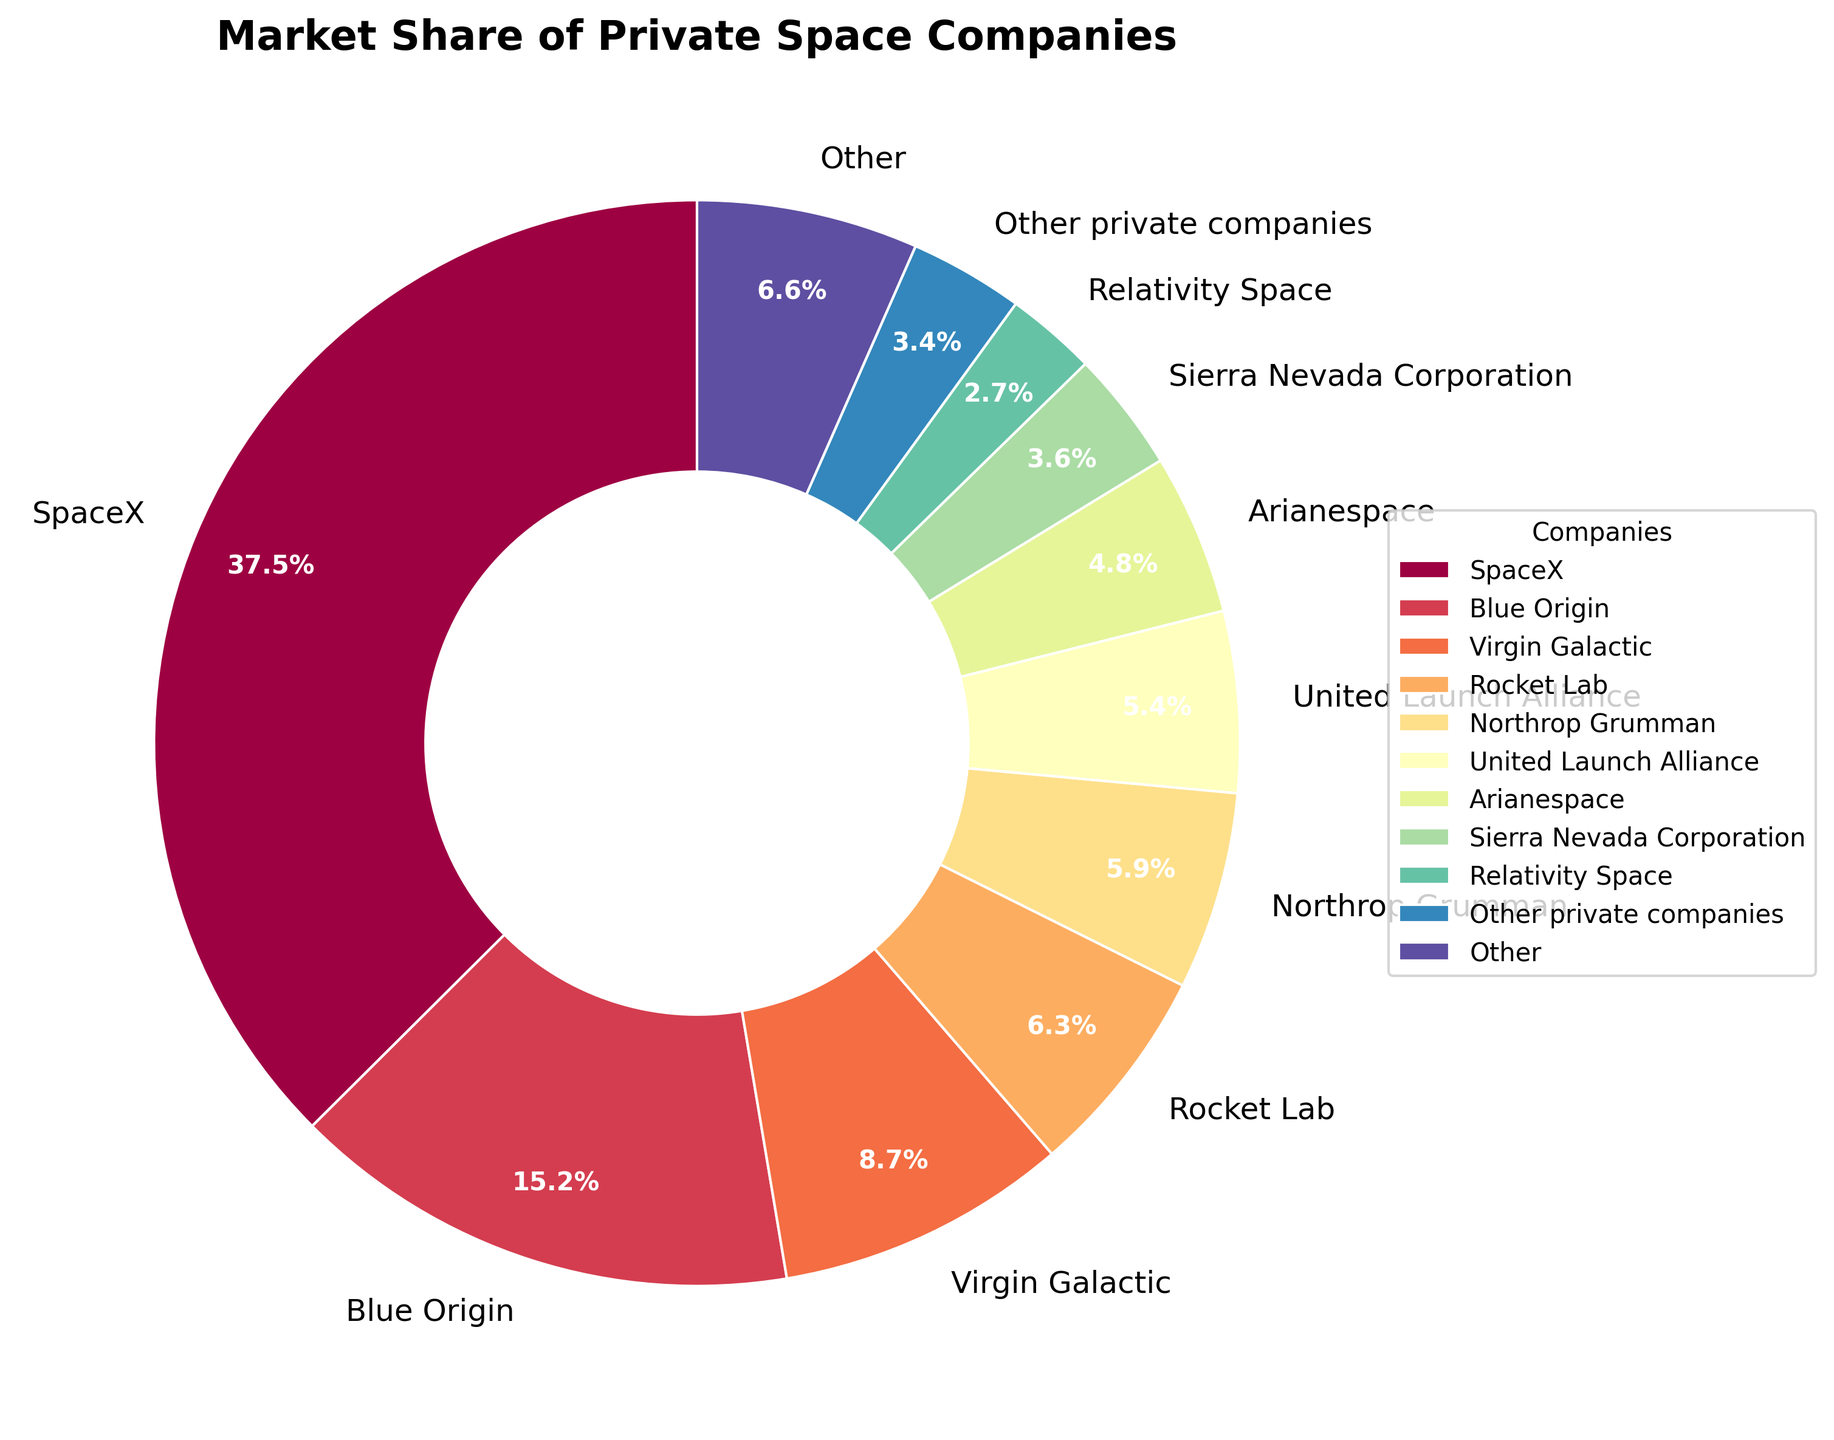What are the two companies with the highest market share? The pie chart shows SpaceX and Blue Origin with the largest slices of the pie. The labels indicate SpaceX has a market share of 37.5% and Blue Origin 15.2%.
Answer: SpaceX and Blue Origin Which company has a higher market share, Virgin Galactic or Rocket Lab? By comparing the labeled market shares, Virgin Galactic has 8.7% while Rocket Lab has 6.3%. Virgin Galactic's share is greater.
Answer: Virgin Galactic What is the combined market share of Northrop Grumman and United Launch Alliance? The pie chart labels Northrop Grumman with 5.9% and United Launch Alliance with 5.4%. Adding them together, 5.9 + 5.4 = 11.3%.
Answer: 11.3% Which company's market share is indicated by a segment next to the "Other" category? According to the slice arrangement, Axiom Space is next to "Other" and has a market share of 0.5%.
Answer: Axiom Space How many companies individually have above a 10% market share? By reviewing the pie chart labels, only SpaceX (37.5%) and Blue Origin (15.2%) surpass the 10% threshold. That makes two companies.
Answer: 2 Compare the market shares of Relativity Space and Rocket Lab. Which is larger and by how much? Relativity Space has a market share of 2.7%, and Rocket Lab has 6.3%. The difference is 6.3 - 2.7 = 3.6%. Rocket Lab's share is larger by 3.6%.
Answer: Rocket Lab by 3.6% What is the average market share of companies other than SpaceX, Blue Origin, and Virgin Galactic combined? Excluding SpaceX, Blue Origin, and Virgin Galactic, the following companies remain: Rocket Lab, Northrop Grumman, United Launch Alliance, Arianespace, Sierra Nevada Corporation, Relativity Space, Firefly Aerospace, Astra, Vector Launch, Astrobotic, Planet Labs, Axiom Space, and Other. Summing their shares: 6.3 + 5.9 + 5.4 + 4.8 + 3.6 + 2.7 + 1.9 + 1.5 + 1.2 + 0.8 + 0.7 + 0.5 + 3.4 = 38.7%. The number of companies is 13, so the average is 38.7 / 13 ≈ 2.98%.
Answer: 2.98% Identify the company with the smallest market share shown and the corresponding percentage. The chart indicates that Axiom Space, with a market share of 0.5%, has the smallest slice other than those categorized as "Other."
Answer: Axiom Space, 0.5% What percentage of the market do companies other than SpaceX, Blue Origin, and Virgin Galactic represent combined? The combined market share of SpaceX, Blue Origin, and Virgin Galactic is 37.5 + 15.2 + 8.7 = 61.4%. The pie chart represents 100%, so the remaining companies equal 100 - 61.4 = 38.6%.
Answer: 38.6% 